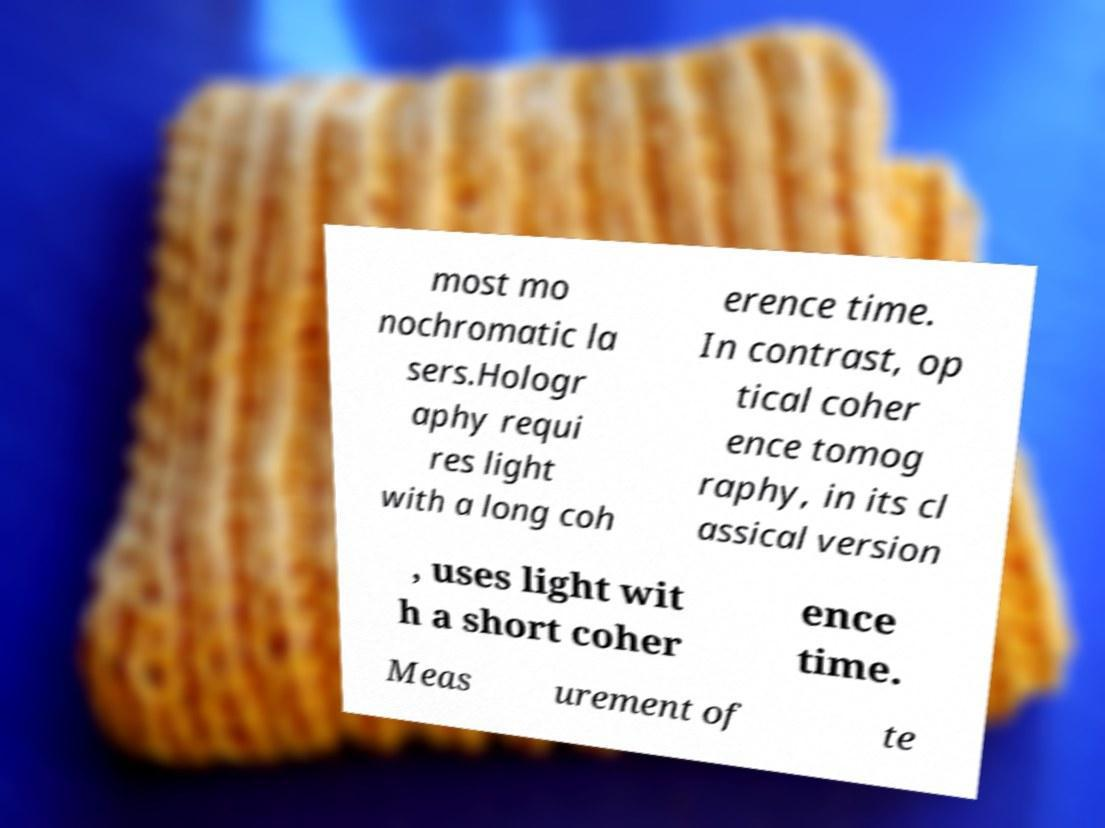Can you read and provide the text displayed in the image?This photo seems to have some interesting text. Can you extract and type it out for me? most mo nochromatic la sers.Hologr aphy requi res light with a long coh erence time. In contrast, op tical coher ence tomog raphy, in its cl assical version , uses light wit h a short coher ence time. Meas urement of te 